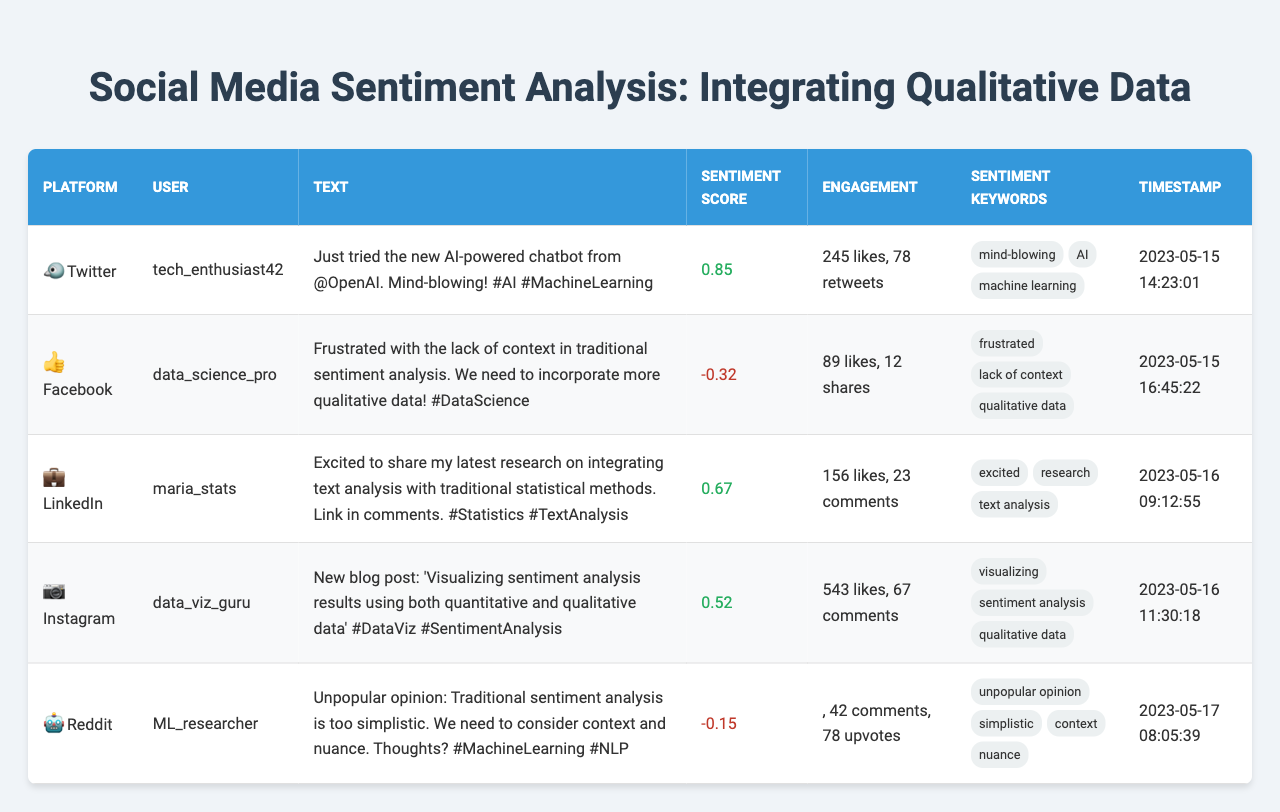What is the sentiment score of the post from Twitter? The Twitter post is authored by tech_enthusiast42, and it has a sentiment score of 0.85.
Answer: 0.85 Which post has the highest number of likes? The post by data_viz_guru on Instagram has 543 likes, which is the highest among all posts listed.
Answer: 543 How many total comments are there across all posts? The total number of comments is the sum of comments in each post: 0 (Twitter) + 0 (Facebook) + 23 (LinkedIn) + 67 (Instagram) + 42 (Reddit) = 132 comments total.
Answer: 132 Is there a post with a negative sentiment score? Yes, the post by data_science_pro on Facebook has a negative sentiment score of -0.32.
Answer: Yes What is the average sentiment score of all posts? Calculate the average by summing the sentiment scores: 0.85 (Twitter) + (-0.32) (Facebook) + 0.67 (LinkedIn) + 0.52 (Instagram) + (-0.15) (Reddit) = 1.57. Then divide by the number of posts (5): 1.57 / 5 = 0.314.
Answer: 0.314 Which platform has the most combined engagement from likes/shares/comments/upvotes? Calculate engagement for each platform by adding their respective metrics. The platforms have the following engagement: Twitter: 245 likes + 78 retweets = 323; Facebook: 89 likes + 12 shares = 101; LinkedIn: 156 likes + 23 comments = 179; Instagram: 543 likes + 67 comments = 610; Reddit: 78 upvotes + 42 comments = 120. Instagram has the highest engagement with 610.
Answer: Instagram Do any posts explicitly mention the need for qualitative data? Yes, the post by data_science_pro on Facebook mentions, "We need to incorporate more qualitative data!"
Answer: Yes What is the total number of posts that have "AI" as a sentiment keyword? The posts containing the keyword "AI" are from tech_enthusiast42 (Twitter) and ML_researcher (Reddit). Counting these, we find 2 posts.
Answer: 2 Which user has the highest engagement score? Calculate engagement for each user: tech_enthusiast42 (Twitter) = 323; data_science_pro (Facebook) = 101; maria_stats (LinkedIn) = 179; data_viz_guru (Instagram) = 610; ML_researcher (Reddit) = 120. The user with the highest is data_viz_guru with 610.
Answer: data_viz_guru How many total likes do the posts with a sentiment score above 0.5 receive? The posts with score above 0.5 are from tech_enthusiast42 (245 likes) and data_viz_guru (543 likes). Adding these gives 245 + 543 = 788 likes total.
Answer: 788 